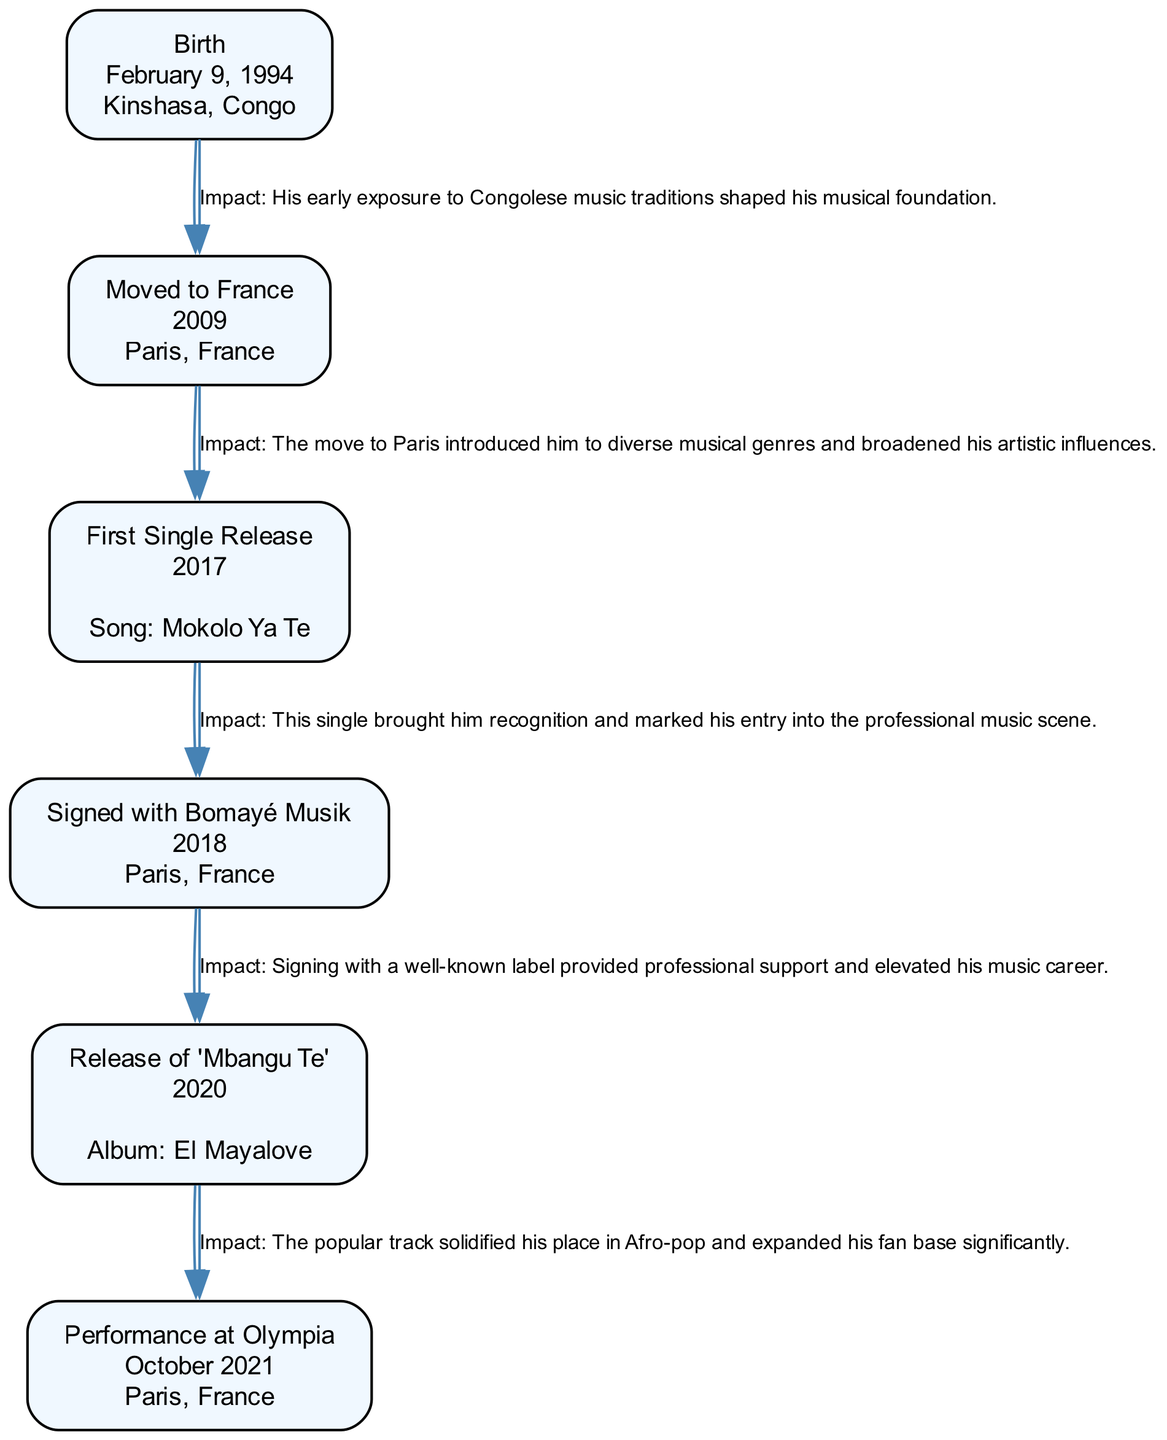What is the date of Ya Levis's birth? The diagram indicates that Ya Levis was born on February 9, 1994. This date is clearly labeled under the "Birth" node.
Answer: February 9, 1994 Where did Ya Levis move to in 2009? The diagram shows the event "Moved to France" and lists Paris, France as the location. This information is part of the label in the corresponding node.
Answer: Paris, France What was the title of Ya Levis's first single? According to the "First Single Release" node, the title of his first single is "Mokolo Ya Te," which is explicitly noted in that node.
Answer: Mokolo Ya Te How many life events are documented in the diagram? By counting the nodes in the diagram, it is noted that there are six key life events listed, each represented as a separate node.
Answer: 6 Which event occurred in October 2021? The diagram indicates "Performance at Olympia" is the event that took place in October 2021, as shown in the corresponding node.
Answer: Performance at Olympia What was the impact of signing with Bomayé Musik? The edge leading from "Signed with Bomayé Musik" notes that it provided professional support, which elevated his music career, thus affecting the subsequent node.
Answer: Elevated his music career Which song released in 2020 solidified his place in Afro-pop? The diagram identifies the song "Mbangu Te" released in 2020 under the node "Release of 'Mbangu Te'", emphasizing its significance.
Answer: Mbangu Te How did moving to Paris influence Ya Levis's music? The impact from the "Moved to France" event states that it introduced him to diverse musical genres and broadened his artistic influences, showing how it affected his music.
Answer: Broadened his artistic influences Who performed at the Olympia venue? The diagram indicates that Ya Levis is the performer at the Olympia venue as stated in the "Performance at Olympia" node, directly referencing his achievement.
Answer: Ya Levis What is the name of the album associated with the release of "Mbangu Te"? The diagram specifies that the song "Mbangu Te" was part of the album "El Mayalove," providing a direct connection between the song and its album.
Answer: El Mayalove 